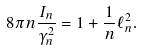Convert formula to latex. <formula><loc_0><loc_0><loc_500><loc_500>8 \pi n \frac { I _ { n } } { \gamma _ { n } ^ { 2 } } = 1 + \frac { 1 } { n } \ell ^ { 2 } _ { n } .</formula> 